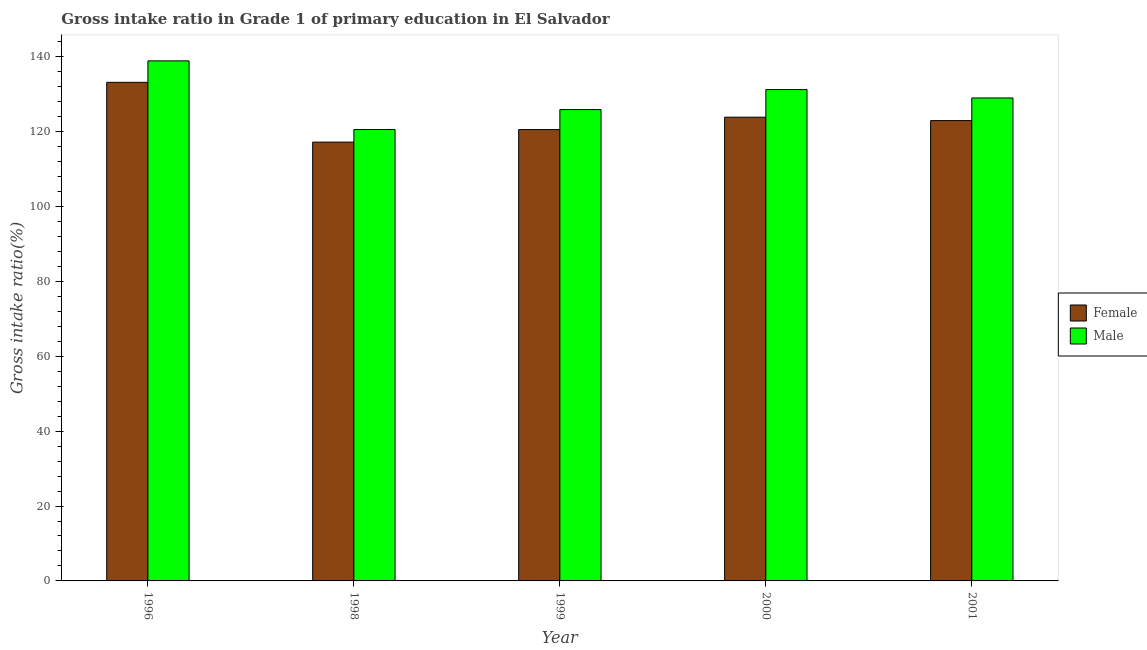How many different coloured bars are there?
Ensure brevity in your answer.  2. How many groups of bars are there?
Your answer should be compact. 5. How many bars are there on the 3rd tick from the left?
Your answer should be compact. 2. How many bars are there on the 1st tick from the right?
Make the answer very short. 2. What is the label of the 1st group of bars from the left?
Make the answer very short. 1996. What is the gross intake ratio(female) in 2000?
Provide a succinct answer. 123.86. Across all years, what is the maximum gross intake ratio(male)?
Give a very brief answer. 138.9. Across all years, what is the minimum gross intake ratio(male)?
Keep it short and to the point. 120.56. What is the total gross intake ratio(male) in the graph?
Your answer should be compact. 645.6. What is the difference between the gross intake ratio(female) in 1999 and that in 2001?
Provide a succinct answer. -2.4. What is the difference between the gross intake ratio(female) in 1998 and the gross intake ratio(male) in 1996?
Ensure brevity in your answer.  -15.97. What is the average gross intake ratio(female) per year?
Ensure brevity in your answer.  123.55. In the year 2000, what is the difference between the gross intake ratio(female) and gross intake ratio(male)?
Provide a short and direct response. 0. What is the ratio of the gross intake ratio(male) in 1998 to that in 1999?
Your answer should be compact. 0.96. Is the gross intake ratio(female) in 1999 less than that in 2000?
Your answer should be very brief. Yes. Is the difference between the gross intake ratio(male) in 1998 and 2000 greater than the difference between the gross intake ratio(female) in 1998 and 2000?
Make the answer very short. No. What is the difference between the highest and the second highest gross intake ratio(male)?
Your response must be concise. 7.66. What is the difference between the highest and the lowest gross intake ratio(male)?
Your answer should be compact. 18.34. What does the 2nd bar from the left in 1998 represents?
Offer a terse response. Male. What is the difference between two consecutive major ticks on the Y-axis?
Keep it short and to the point. 20. Does the graph contain any zero values?
Offer a very short reply. No. Does the graph contain grids?
Keep it short and to the point. No. How many legend labels are there?
Your answer should be very brief. 2. How are the legend labels stacked?
Your answer should be very brief. Vertical. What is the title of the graph?
Ensure brevity in your answer.  Gross intake ratio in Grade 1 of primary education in El Salvador. Does "Urban" appear as one of the legend labels in the graph?
Offer a terse response. No. What is the label or title of the X-axis?
Offer a very short reply. Year. What is the label or title of the Y-axis?
Ensure brevity in your answer.  Gross intake ratio(%). What is the Gross intake ratio(%) in Female in 1996?
Your response must be concise. 133.17. What is the Gross intake ratio(%) in Male in 1996?
Your response must be concise. 138.9. What is the Gross intake ratio(%) in Female in 1998?
Ensure brevity in your answer.  117.2. What is the Gross intake ratio(%) of Male in 1998?
Give a very brief answer. 120.56. What is the Gross intake ratio(%) in Female in 1999?
Offer a very short reply. 120.55. What is the Gross intake ratio(%) of Male in 1999?
Provide a short and direct response. 125.9. What is the Gross intake ratio(%) of Female in 2000?
Your answer should be very brief. 123.86. What is the Gross intake ratio(%) of Male in 2000?
Keep it short and to the point. 131.24. What is the Gross intake ratio(%) in Female in 2001?
Ensure brevity in your answer.  122.95. What is the Gross intake ratio(%) of Male in 2001?
Provide a short and direct response. 129. Across all years, what is the maximum Gross intake ratio(%) of Female?
Your answer should be compact. 133.17. Across all years, what is the maximum Gross intake ratio(%) of Male?
Give a very brief answer. 138.9. Across all years, what is the minimum Gross intake ratio(%) in Female?
Keep it short and to the point. 117.2. Across all years, what is the minimum Gross intake ratio(%) in Male?
Make the answer very short. 120.56. What is the total Gross intake ratio(%) in Female in the graph?
Provide a succinct answer. 617.74. What is the total Gross intake ratio(%) in Male in the graph?
Keep it short and to the point. 645.6. What is the difference between the Gross intake ratio(%) in Female in 1996 and that in 1998?
Your answer should be compact. 15.97. What is the difference between the Gross intake ratio(%) of Male in 1996 and that in 1998?
Your response must be concise. 18.34. What is the difference between the Gross intake ratio(%) in Female in 1996 and that in 1999?
Offer a very short reply. 12.62. What is the difference between the Gross intake ratio(%) in Male in 1996 and that in 1999?
Your answer should be compact. 13.01. What is the difference between the Gross intake ratio(%) in Female in 1996 and that in 2000?
Ensure brevity in your answer.  9.31. What is the difference between the Gross intake ratio(%) in Male in 1996 and that in 2000?
Your response must be concise. 7.66. What is the difference between the Gross intake ratio(%) in Female in 1996 and that in 2001?
Offer a terse response. 10.22. What is the difference between the Gross intake ratio(%) of Male in 1996 and that in 2001?
Ensure brevity in your answer.  9.91. What is the difference between the Gross intake ratio(%) in Female in 1998 and that in 1999?
Make the answer very short. -3.35. What is the difference between the Gross intake ratio(%) of Male in 1998 and that in 1999?
Your response must be concise. -5.33. What is the difference between the Gross intake ratio(%) of Female in 1998 and that in 2000?
Keep it short and to the point. -6.66. What is the difference between the Gross intake ratio(%) of Male in 1998 and that in 2000?
Offer a very short reply. -10.68. What is the difference between the Gross intake ratio(%) in Female in 1998 and that in 2001?
Keep it short and to the point. -5.75. What is the difference between the Gross intake ratio(%) in Male in 1998 and that in 2001?
Your answer should be compact. -8.44. What is the difference between the Gross intake ratio(%) of Female in 1999 and that in 2000?
Make the answer very short. -3.31. What is the difference between the Gross intake ratio(%) of Male in 1999 and that in 2000?
Provide a short and direct response. -5.34. What is the difference between the Gross intake ratio(%) in Female in 1999 and that in 2001?
Your response must be concise. -2.4. What is the difference between the Gross intake ratio(%) of Male in 1999 and that in 2001?
Offer a terse response. -3.1. What is the difference between the Gross intake ratio(%) in Female in 2000 and that in 2001?
Ensure brevity in your answer.  0.91. What is the difference between the Gross intake ratio(%) of Male in 2000 and that in 2001?
Your answer should be compact. 2.24. What is the difference between the Gross intake ratio(%) in Female in 1996 and the Gross intake ratio(%) in Male in 1998?
Your answer should be very brief. 12.61. What is the difference between the Gross intake ratio(%) in Female in 1996 and the Gross intake ratio(%) in Male in 1999?
Make the answer very short. 7.28. What is the difference between the Gross intake ratio(%) of Female in 1996 and the Gross intake ratio(%) of Male in 2000?
Your answer should be very brief. 1.93. What is the difference between the Gross intake ratio(%) of Female in 1996 and the Gross intake ratio(%) of Male in 2001?
Your answer should be very brief. 4.17. What is the difference between the Gross intake ratio(%) in Female in 1998 and the Gross intake ratio(%) in Male in 1999?
Provide a short and direct response. -8.69. What is the difference between the Gross intake ratio(%) in Female in 1998 and the Gross intake ratio(%) in Male in 2000?
Make the answer very short. -14.04. What is the difference between the Gross intake ratio(%) in Female in 1998 and the Gross intake ratio(%) in Male in 2001?
Your answer should be very brief. -11.79. What is the difference between the Gross intake ratio(%) in Female in 1999 and the Gross intake ratio(%) in Male in 2000?
Your answer should be compact. -10.69. What is the difference between the Gross intake ratio(%) of Female in 1999 and the Gross intake ratio(%) of Male in 2001?
Your answer should be very brief. -8.45. What is the difference between the Gross intake ratio(%) of Female in 2000 and the Gross intake ratio(%) of Male in 2001?
Your answer should be compact. -5.14. What is the average Gross intake ratio(%) of Female per year?
Provide a short and direct response. 123.55. What is the average Gross intake ratio(%) of Male per year?
Provide a succinct answer. 129.12. In the year 1996, what is the difference between the Gross intake ratio(%) in Female and Gross intake ratio(%) in Male?
Your answer should be compact. -5.73. In the year 1998, what is the difference between the Gross intake ratio(%) in Female and Gross intake ratio(%) in Male?
Give a very brief answer. -3.36. In the year 1999, what is the difference between the Gross intake ratio(%) of Female and Gross intake ratio(%) of Male?
Make the answer very short. -5.35. In the year 2000, what is the difference between the Gross intake ratio(%) of Female and Gross intake ratio(%) of Male?
Your answer should be very brief. -7.38. In the year 2001, what is the difference between the Gross intake ratio(%) of Female and Gross intake ratio(%) of Male?
Give a very brief answer. -6.05. What is the ratio of the Gross intake ratio(%) of Female in 1996 to that in 1998?
Give a very brief answer. 1.14. What is the ratio of the Gross intake ratio(%) in Male in 1996 to that in 1998?
Give a very brief answer. 1.15. What is the ratio of the Gross intake ratio(%) of Female in 1996 to that in 1999?
Your answer should be very brief. 1.1. What is the ratio of the Gross intake ratio(%) of Male in 1996 to that in 1999?
Offer a very short reply. 1.1. What is the ratio of the Gross intake ratio(%) of Female in 1996 to that in 2000?
Make the answer very short. 1.08. What is the ratio of the Gross intake ratio(%) in Male in 1996 to that in 2000?
Make the answer very short. 1.06. What is the ratio of the Gross intake ratio(%) in Female in 1996 to that in 2001?
Your answer should be very brief. 1.08. What is the ratio of the Gross intake ratio(%) in Male in 1996 to that in 2001?
Offer a terse response. 1.08. What is the ratio of the Gross intake ratio(%) in Female in 1998 to that in 1999?
Make the answer very short. 0.97. What is the ratio of the Gross intake ratio(%) in Male in 1998 to that in 1999?
Your answer should be compact. 0.96. What is the ratio of the Gross intake ratio(%) of Female in 1998 to that in 2000?
Your response must be concise. 0.95. What is the ratio of the Gross intake ratio(%) in Male in 1998 to that in 2000?
Provide a short and direct response. 0.92. What is the ratio of the Gross intake ratio(%) in Female in 1998 to that in 2001?
Provide a succinct answer. 0.95. What is the ratio of the Gross intake ratio(%) in Male in 1998 to that in 2001?
Keep it short and to the point. 0.93. What is the ratio of the Gross intake ratio(%) in Female in 1999 to that in 2000?
Make the answer very short. 0.97. What is the ratio of the Gross intake ratio(%) in Male in 1999 to that in 2000?
Provide a short and direct response. 0.96. What is the ratio of the Gross intake ratio(%) of Female in 1999 to that in 2001?
Provide a succinct answer. 0.98. What is the ratio of the Gross intake ratio(%) in Female in 2000 to that in 2001?
Give a very brief answer. 1.01. What is the ratio of the Gross intake ratio(%) of Male in 2000 to that in 2001?
Your response must be concise. 1.02. What is the difference between the highest and the second highest Gross intake ratio(%) in Female?
Provide a short and direct response. 9.31. What is the difference between the highest and the second highest Gross intake ratio(%) in Male?
Keep it short and to the point. 7.66. What is the difference between the highest and the lowest Gross intake ratio(%) of Female?
Keep it short and to the point. 15.97. What is the difference between the highest and the lowest Gross intake ratio(%) in Male?
Your response must be concise. 18.34. 